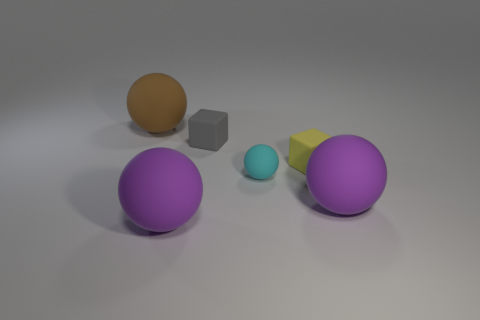Subtract all large brown matte balls. How many balls are left? 3 Subtract 1 blocks. How many blocks are left? 1 Subtract all cyan balls. How many balls are left? 3 Add 4 yellow rubber cubes. How many objects exist? 10 Subtract all green spheres. How many purple blocks are left? 0 Subtract all tiny blue objects. Subtract all gray blocks. How many objects are left? 5 Add 4 large purple rubber spheres. How many large purple rubber spheres are left? 6 Add 3 yellow metal cubes. How many yellow metal cubes exist? 3 Subtract 0 red cylinders. How many objects are left? 6 Subtract all cubes. How many objects are left? 4 